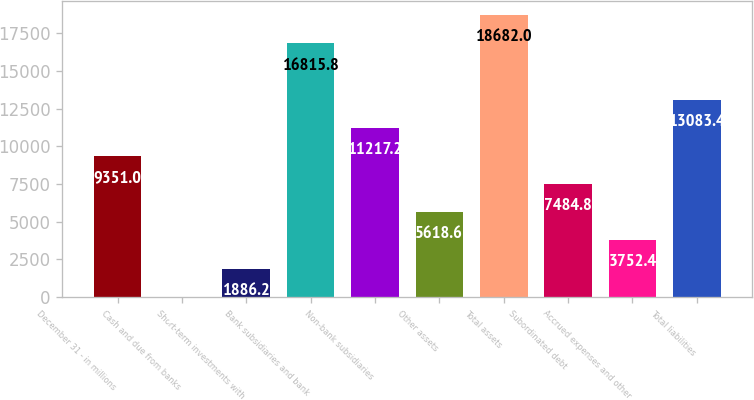<chart> <loc_0><loc_0><loc_500><loc_500><bar_chart><fcel>December 31 - in millions<fcel>Cash and due from banks<fcel>Short-term investments with<fcel>Bank subsidiaries and bank<fcel>Non-bank subsidiaries<fcel>Other assets<fcel>Total assets<fcel>Subordinated debt<fcel>Accrued expenses and other<fcel>Total liabilities<nl><fcel>9351<fcel>20<fcel>1886.2<fcel>16815.8<fcel>11217.2<fcel>5618.6<fcel>18682<fcel>7484.8<fcel>3752.4<fcel>13083.4<nl></chart> 